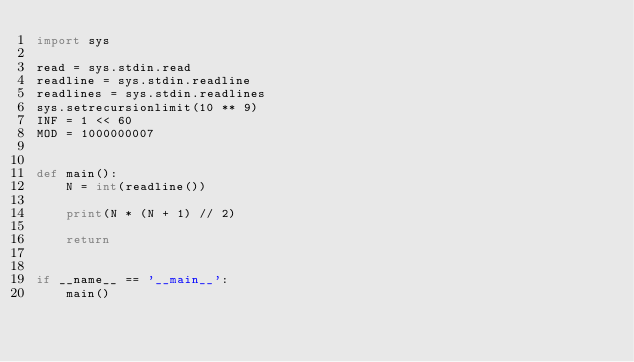<code> <loc_0><loc_0><loc_500><loc_500><_Python_>import sys

read = sys.stdin.read
readline = sys.stdin.readline
readlines = sys.stdin.readlines
sys.setrecursionlimit(10 ** 9)
INF = 1 << 60
MOD = 1000000007


def main():
    N = int(readline())

    print(N * (N + 1) // 2)

    return


if __name__ == '__main__':
    main()
</code> 